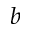Convert formula to latex. <formula><loc_0><loc_0><loc_500><loc_500>b</formula> 